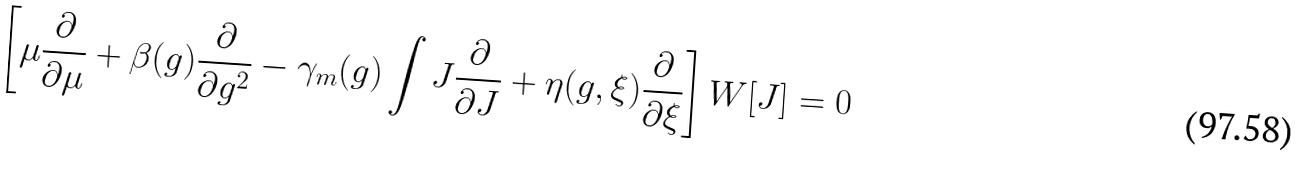<formula> <loc_0><loc_0><loc_500><loc_500>\left [ \mu \frac { \partial } { \partial \mu } + \beta ( g ) \frac { \partial } { \partial g ^ { 2 } } - \gamma _ { m } ( g ) \int J \frac { \partial } { \partial J } + \eta ( g , \xi ) \frac { \partial } { \partial \xi } \right ] W [ J ] = 0</formula> 